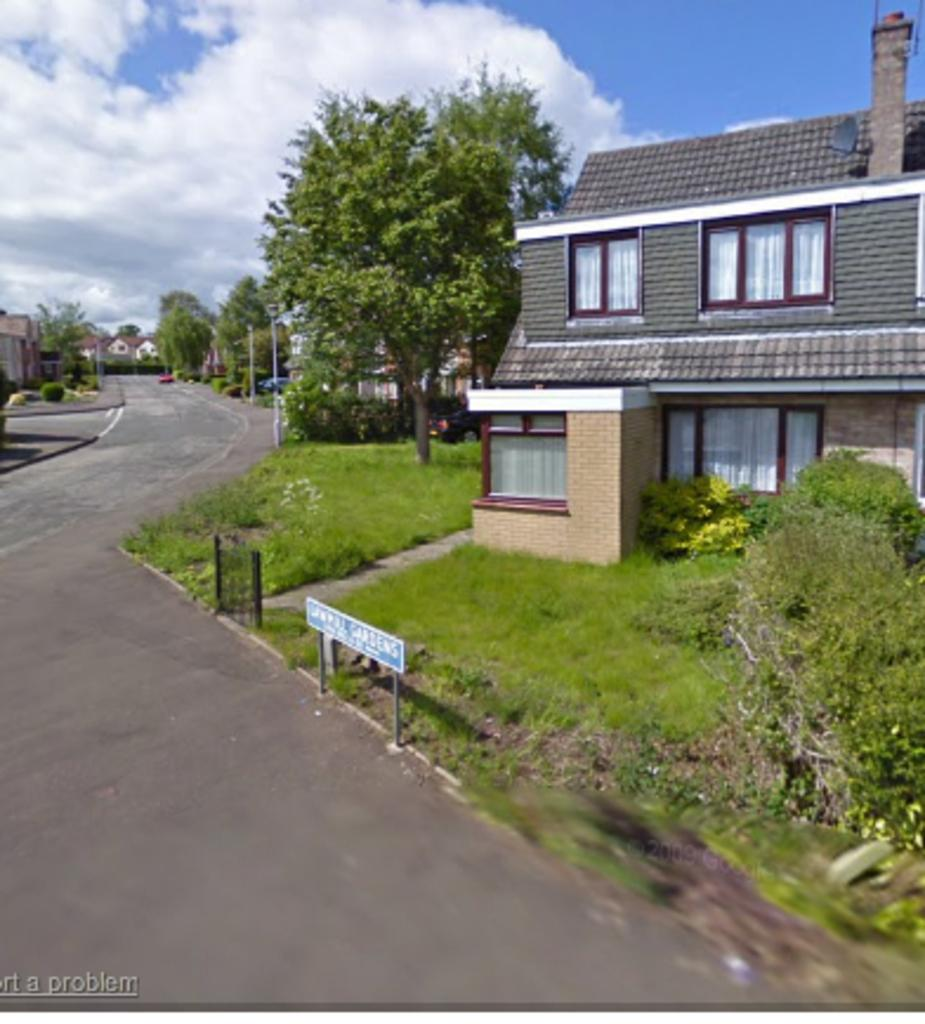What is located on the left side of the image? There is a road on the left side of the image. What can be seen on both sides of the road? There are buildings on either side of the road. What type of vegetation is in front of the buildings? Trees are present in front of the buildings on the grassland. What is visible above the road and buildings? The sky is visible above the road and buildings. What can be observed in the sky? Clouds are present in the sky. How many cattle are grazing on the grassland in the image? There are no cattle present in the image; it features a road, buildings, trees, and a sky with clouds. What type of selection process is being conducted in the image? There is no selection process depicted in the image; it shows a road, buildings, trees, and a sky with clouds. 